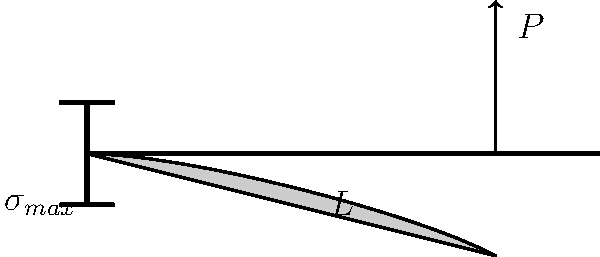If you were to create a #StressDistribution challenge for Vine (RIP), how would you explain the maximum stress in a cantilever beam under a point load $P$ at its free end? Express your answer in terms of the load $P$, beam length $L$, and the section modulus $Z$. Let's break this down in a way that would make for a viral Vine:

1. Picture the beam as your arm holding a heavy smartphone at the end (that's our point load $P$).

2. The stress distribution looks like a triangle, with the maximum stress at the fixed end (your shoulder).

3. The bending moment $M$ at the fixed end is:
   $$M = P \cdot L$$

4. The section modulus $Z$ relates the bending moment to the maximum stress:
   $$\sigma_{max} = \frac{M}{Z}$$

5. Substituting the moment equation into the stress equation:
   $$\sigma_{max} = \frac{P \cdot L}{Z}$$

6. And there you have it! The maximum stress equation, ready for your 6-second engineering Vine!
Answer: $\sigma_{max} = \frac{P \cdot L}{Z}$ 